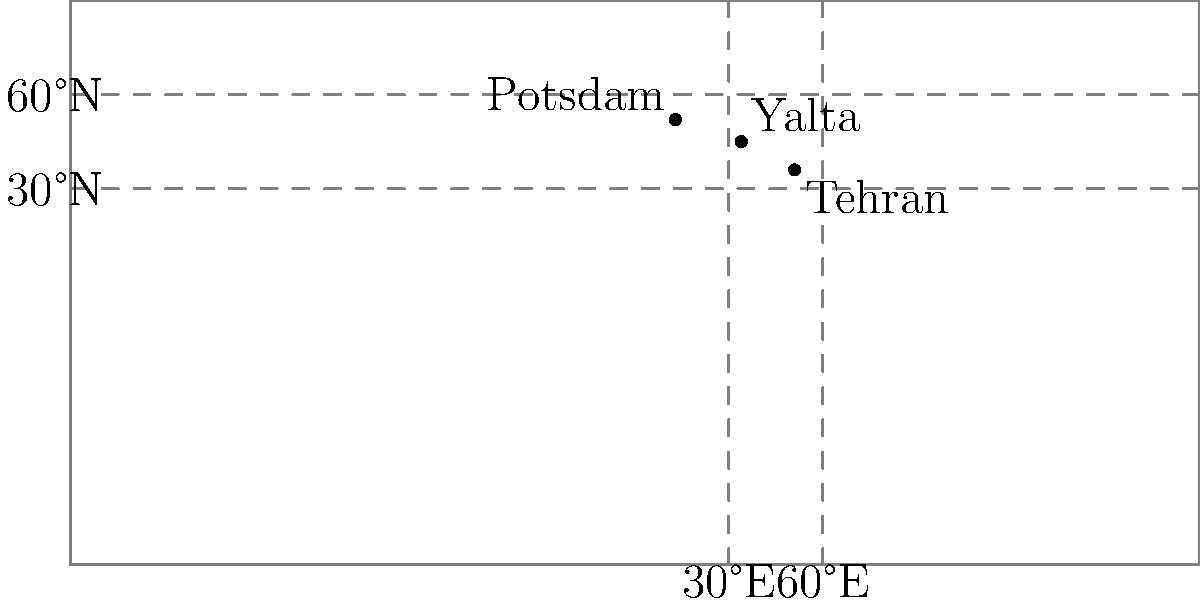During World War II, three crucial diplomatic meetings took place: the Tehran Conference, the Yalta Conference, and the Potsdam Conference. Using the world map provided, which of these conferences occurred at the most eastern longitude? To determine which conference occurred at the most eastern longitude, we need to compare the longitude coordinates of each location:

1. Tehran Conference: Tehran, Iran (51°E)
2. Yalta Conference: Yalta, Crimea (34°E)
3. Potsdam Conference: Potsdam, Germany (13°E)

Comparing these longitudes:
- Tehran is at 51°E
- Yalta is at 34°E
- Potsdam is at 13°E

The most eastern longitude is the largest number when moving from 0° towards 180°E. Therefore, Tehran at 51°E is the most eastern of the three locations.
Answer: Tehran Conference 